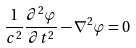<formula> <loc_0><loc_0><loc_500><loc_500>\frac { 1 } { c ^ { 2 } } \frac { \partial ^ { 2 } \varphi } { \partial t ^ { 2 } } - \nabla ^ { 2 } \varphi = 0</formula> 